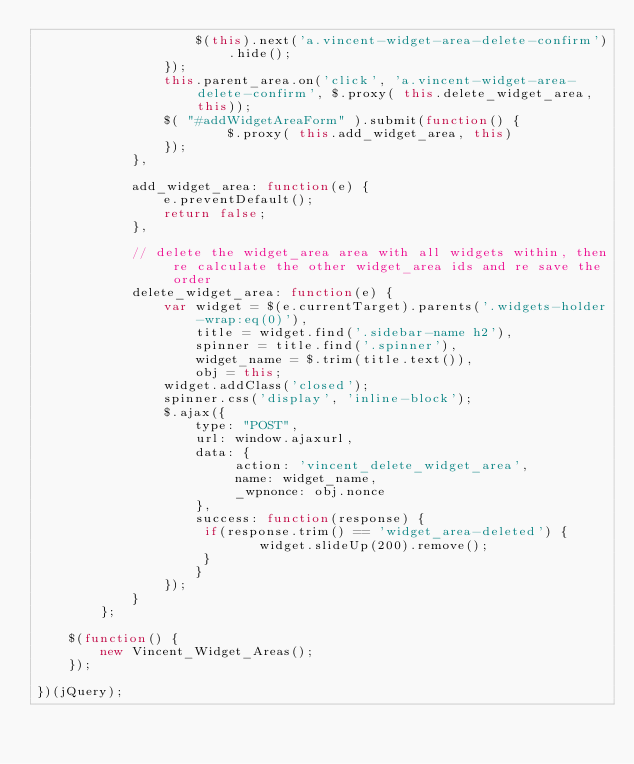<code> <loc_0><loc_0><loc_500><loc_500><_JavaScript_>					$(this).next('a.vincent-widget-area-delete-confirm').hide();
				});
				this.parent_area.on('click', 'a.vincent-widget-area-delete-confirm', $.proxy( this.delete_widget_area, this));
				$( "#addWidgetAreaForm" ).submit(function() {
						$.proxy( this.add_widget_area, this)
				});
			},

			add_widget_area: function(e) {
				e.preventDefault();
				return false;
			},
			
			// delete the widget_area area with all widgets within, then re calculate the other widget_area ids and re save the order
			delete_widget_area: function(e) {
				var widget = $(e.currentTarget).parents('.widgets-holder-wrap:eq(0)'),
					title = widget.find('.sidebar-name h2'),
					spinner = title.find('.spinner'),
					widget_name = $.trim(title.text()),
					obj = this;
				widget.addClass('closed');
				spinner.css('display', 'inline-block');
				$.ajax({
					type: "POST",
					url: window.ajaxurl,
					data: {
						 action: 'vincent_delete_widget_area',
						 name: widget_name,
						 _wpnonce: obj.nonce
					},
					success: function(response) {     
					 if(response.trim() == 'widget_area-deleted') {
							widget.slideUp(200).remove();
					 } 
					}
				});
			}
		};
	
	$(function() {
		new Vincent_Widget_Areas();
	});
	
})(jQuery);  </code> 